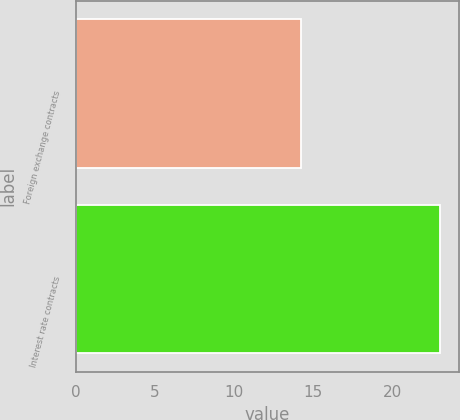<chart> <loc_0><loc_0><loc_500><loc_500><bar_chart><fcel>Foreign exchange contracts<fcel>Interest rate contracts<nl><fcel>14.2<fcel>23<nl></chart> 